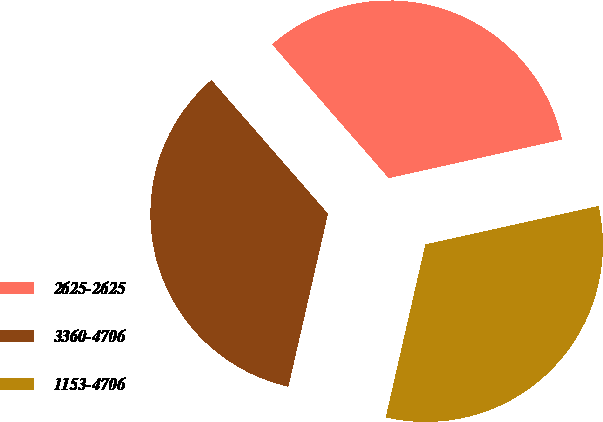Convert chart to OTSL. <chart><loc_0><loc_0><loc_500><loc_500><pie_chart><fcel>2625-2625<fcel>3360-4706<fcel>1153-4706<nl><fcel>32.94%<fcel>35.0%<fcel>32.06%<nl></chart> 